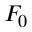<formula> <loc_0><loc_0><loc_500><loc_500>F _ { 0 }</formula> 